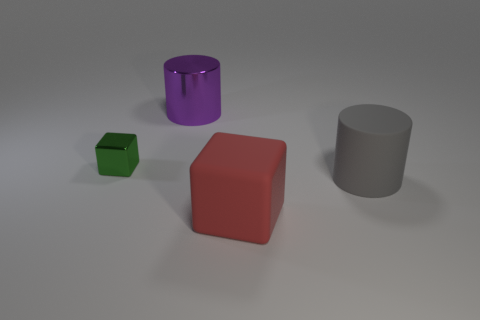Is there any other thing that is the same size as the green metallic cube?
Make the answer very short. No. There is a cylinder right of the purple object; what is its material?
Ensure brevity in your answer.  Rubber. What size is the other object that is the same material as the red thing?
Your answer should be very brief. Large. What number of tiny things are either gray cylinders or purple rubber blocks?
Offer a terse response. 0. How big is the metal thing that is behind the metallic object to the left of the metal thing behind the small green shiny cube?
Your answer should be very brief. Large. What number of red things have the same size as the matte cylinder?
Your response must be concise. 1. How many objects are either big red shiny objects or objects that are on the right side of the purple metal object?
Make the answer very short. 2. What is the shape of the large red object?
Provide a succinct answer. Cube. Do the big rubber cylinder and the big block have the same color?
Ensure brevity in your answer.  No. There is a matte thing that is the same size as the red block; what is its color?
Your response must be concise. Gray. 